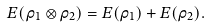<formula> <loc_0><loc_0><loc_500><loc_500>E ( \rho _ { 1 } \otimes \rho _ { 2 } ) = E ( \rho _ { 1 } ) + E ( \rho _ { 2 } ) .</formula> 